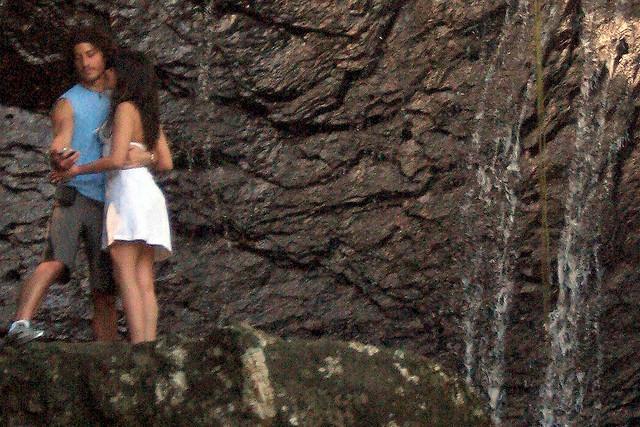How many people are in the photo?
Give a very brief answer. 2. 